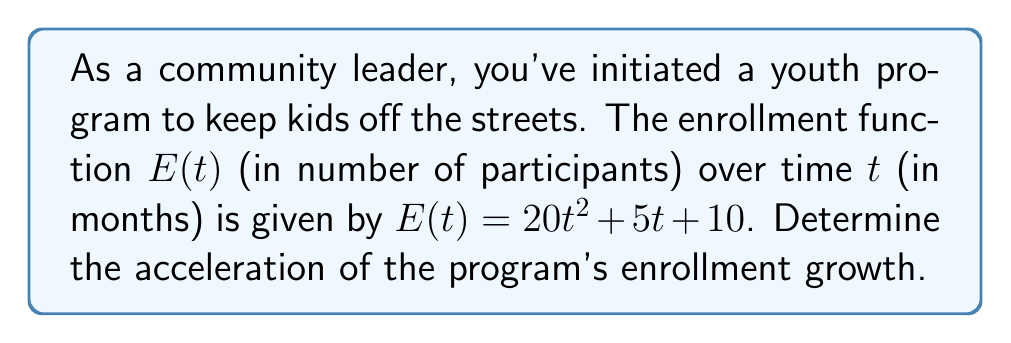Help me with this question. To find the acceleration of the youth program enrollment growth, we need to calculate the second derivative of the enrollment function $E(t)$.

Step 1: Find the first derivative (velocity of enrollment growth)
The first derivative represents the rate of change of enrollment with respect to time.
$$\frac{dE}{dt} = E'(t) = 40t + 5$$

Step 2: Find the second derivative (acceleration of enrollment growth)
The second derivative represents the rate of change of the velocity, which is the acceleration.
$$\frac{d^2E}{dt^2} = E''(t) = 40$$

The acceleration of the youth program enrollment growth is constant and equal to 40 participants per month squared.

This means that the rate at which new participants are joining the program is increasing at a constant rate of 40 participants per month, every month.
Answer: $40$ participants/month² 